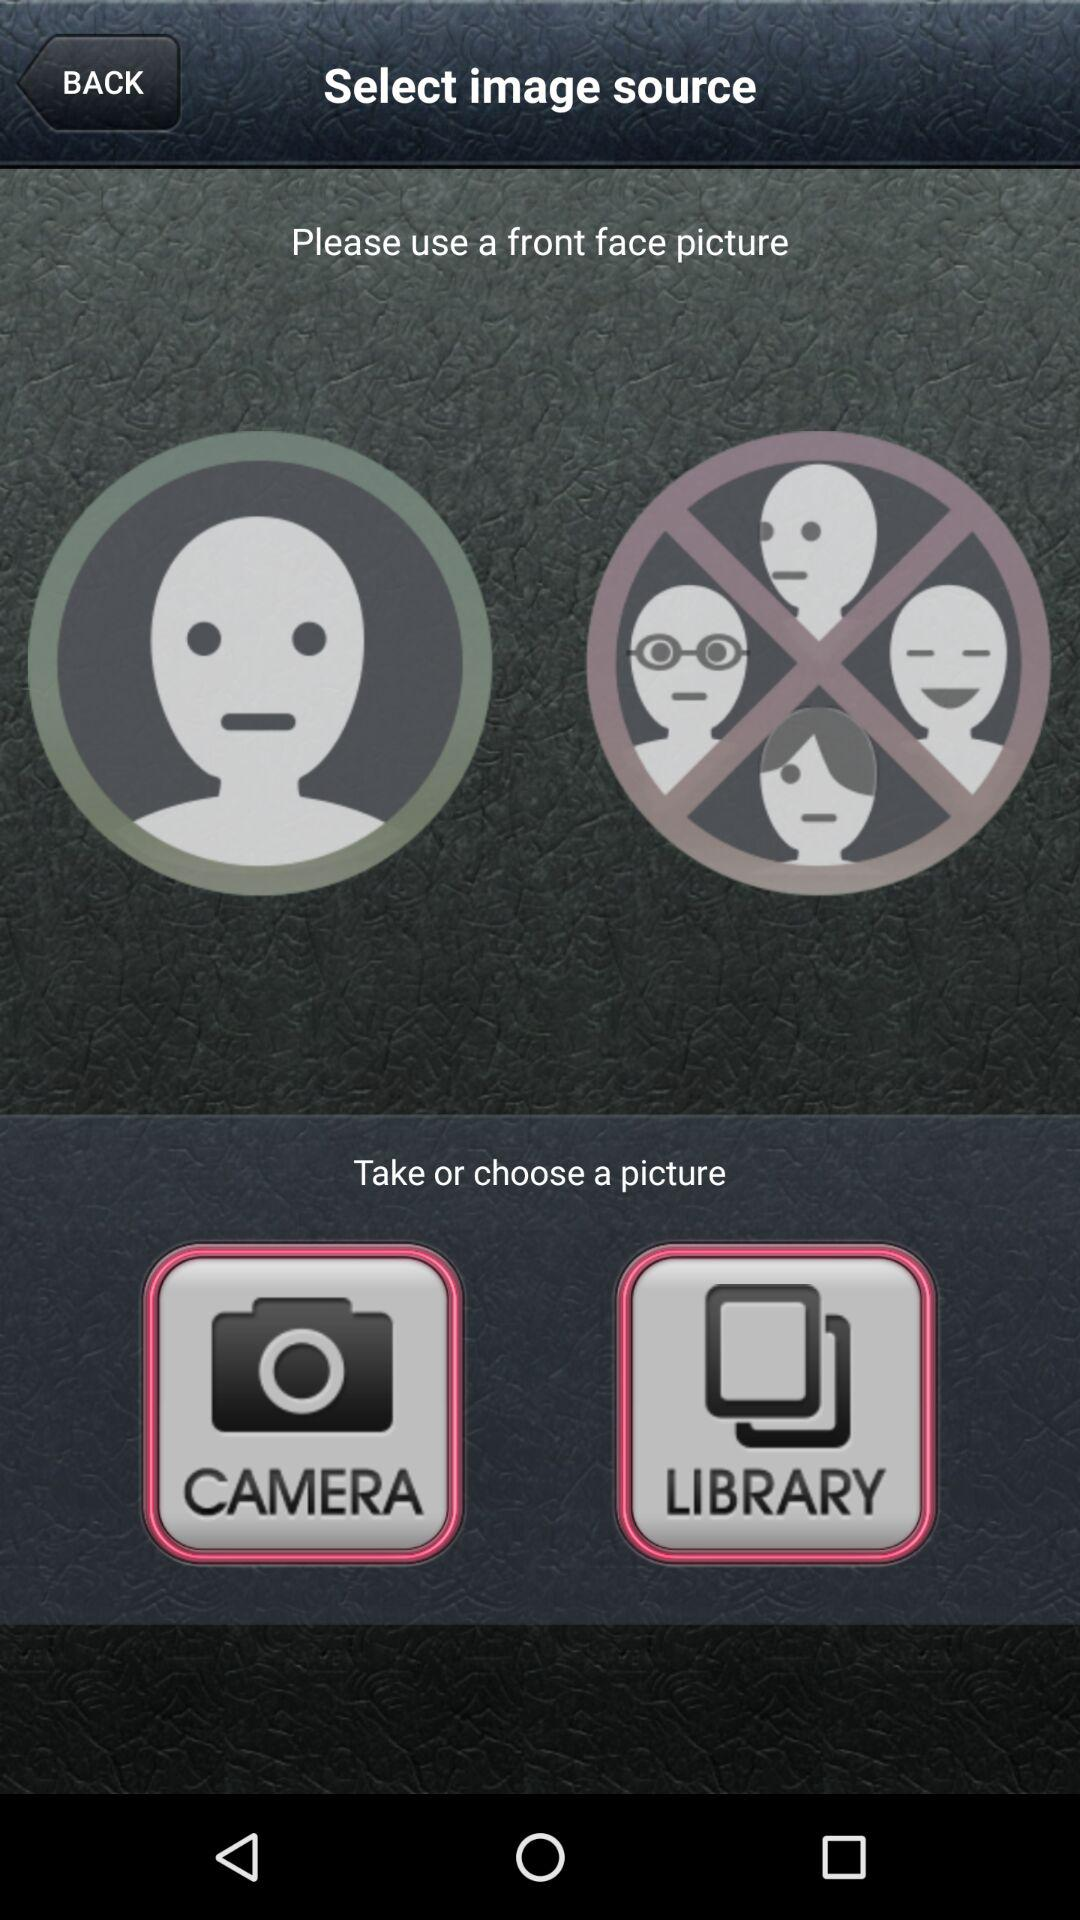What option can be used to upload a picture? The options are "CAMERA" and "LIBRARY". 